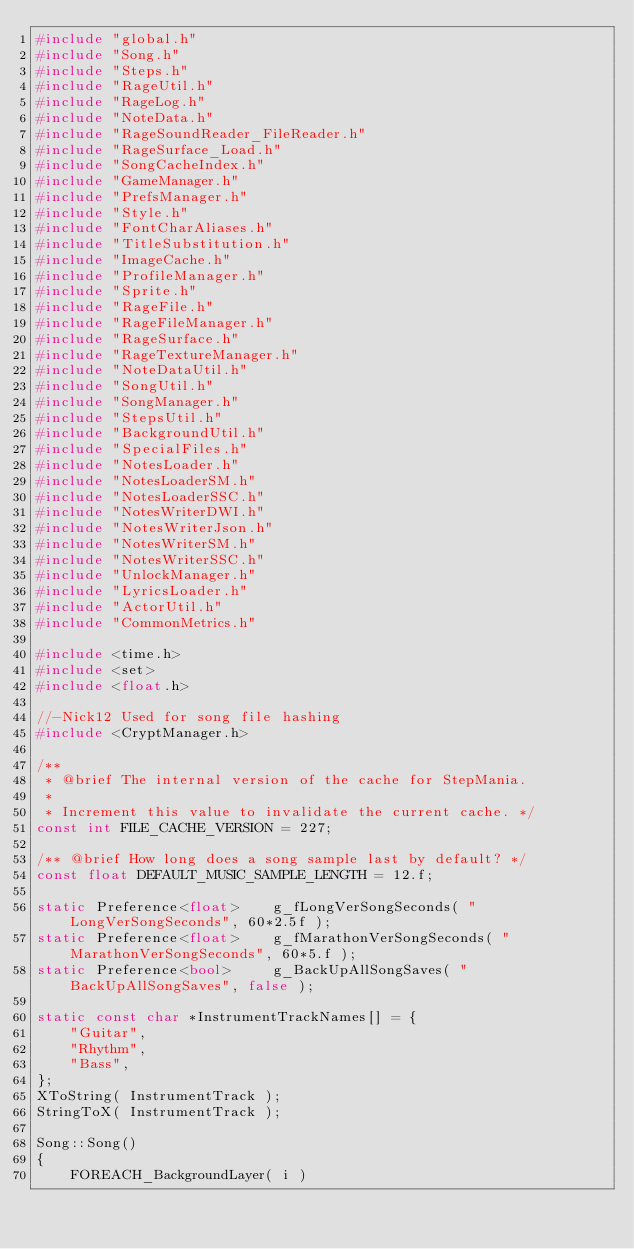<code> <loc_0><loc_0><loc_500><loc_500><_C++_>#include "global.h"
#include "Song.h"
#include "Steps.h"
#include "RageUtil.h"
#include "RageLog.h"
#include "NoteData.h"
#include "RageSoundReader_FileReader.h"
#include "RageSurface_Load.h"
#include "SongCacheIndex.h"
#include "GameManager.h"
#include "PrefsManager.h"
#include "Style.h"
#include "FontCharAliases.h"
#include "TitleSubstitution.h"
#include "ImageCache.h"
#include "ProfileManager.h"
#include "Sprite.h"
#include "RageFile.h"
#include "RageFileManager.h"
#include "RageSurface.h"
#include "RageTextureManager.h"
#include "NoteDataUtil.h"
#include "SongUtil.h"
#include "SongManager.h"
#include "StepsUtil.h"
#include "BackgroundUtil.h"
#include "SpecialFiles.h"
#include "NotesLoader.h"
#include "NotesLoaderSM.h"
#include "NotesLoaderSSC.h"
#include "NotesWriterDWI.h"
#include "NotesWriterJson.h"
#include "NotesWriterSM.h"
#include "NotesWriterSSC.h"
#include "UnlockManager.h"
#include "LyricsLoader.h"
#include "ActorUtil.h"
#include "CommonMetrics.h"

#include <time.h>
#include <set>
#include <float.h>

//-Nick12 Used for song file hashing
#include <CryptManager.h>

/**
 * @brief The internal version of the cache for StepMania.
 *
 * Increment this value to invalidate the current cache. */
const int FILE_CACHE_VERSION = 227;

/** @brief How long does a song sample last by default? */
const float DEFAULT_MUSIC_SAMPLE_LENGTH = 12.f;

static Preference<float>	g_fLongVerSongSeconds( "LongVerSongSeconds", 60*2.5f );
static Preference<float>	g_fMarathonVerSongSeconds( "MarathonVerSongSeconds", 60*5.f );
static Preference<bool>		g_BackUpAllSongSaves( "BackUpAllSongSaves", false );

static const char *InstrumentTrackNames[] = {
	"Guitar",
	"Rhythm",
	"Bass",
};
XToString( InstrumentTrack );
StringToX( InstrumentTrack );

Song::Song()
{
	FOREACH_BackgroundLayer( i )</code> 